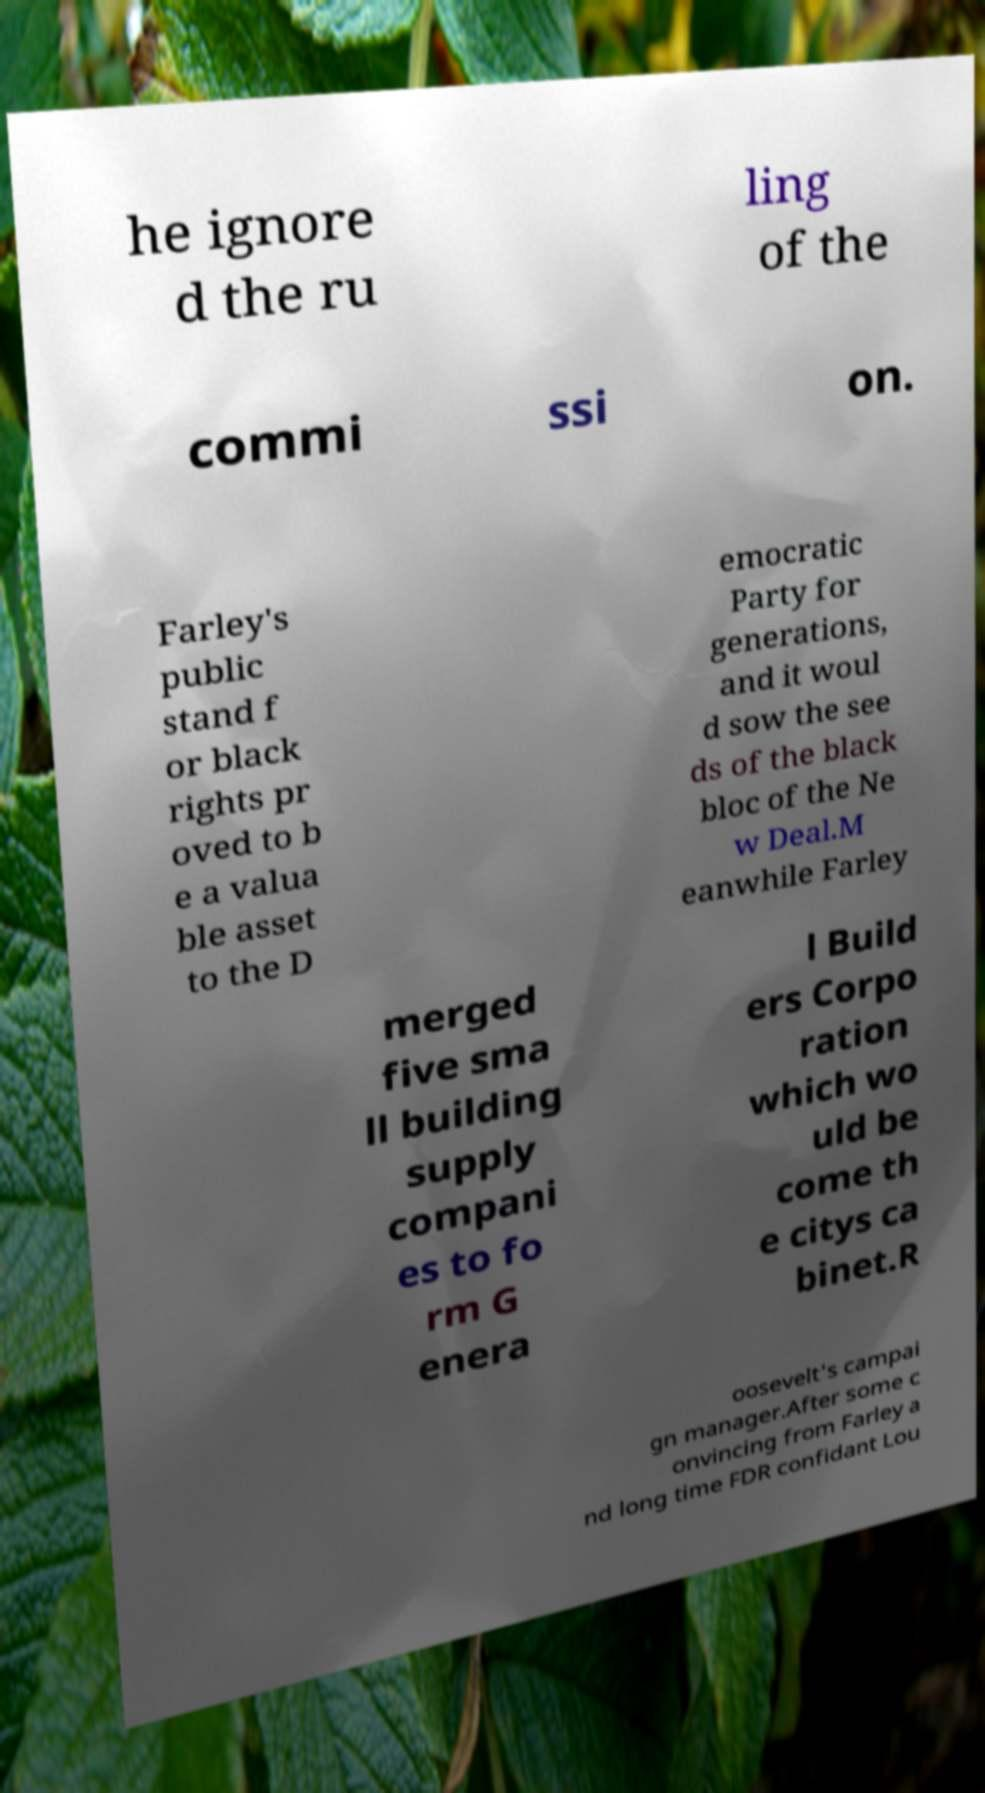Please read and relay the text visible in this image. What does it say? he ignore d the ru ling of the commi ssi on. Farley's public stand f or black rights pr oved to b e a valua ble asset to the D emocratic Party for generations, and it woul d sow the see ds of the black bloc of the Ne w Deal.M eanwhile Farley merged five sma ll building supply compani es to fo rm G enera l Build ers Corpo ration which wo uld be come th e citys ca binet.R oosevelt's campai gn manager.After some c onvincing from Farley a nd long time FDR confidant Lou 